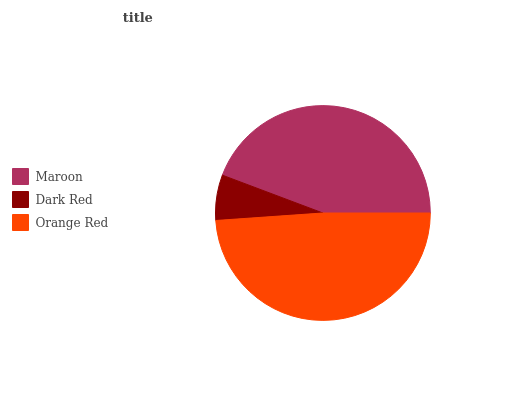Is Dark Red the minimum?
Answer yes or no. Yes. Is Orange Red the maximum?
Answer yes or no. Yes. Is Orange Red the minimum?
Answer yes or no. No. Is Dark Red the maximum?
Answer yes or no. No. Is Orange Red greater than Dark Red?
Answer yes or no. Yes. Is Dark Red less than Orange Red?
Answer yes or no. Yes. Is Dark Red greater than Orange Red?
Answer yes or no. No. Is Orange Red less than Dark Red?
Answer yes or no. No. Is Maroon the high median?
Answer yes or no. Yes. Is Maroon the low median?
Answer yes or no. Yes. Is Dark Red the high median?
Answer yes or no. No. Is Dark Red the low median?
Answer yes or no. No. 